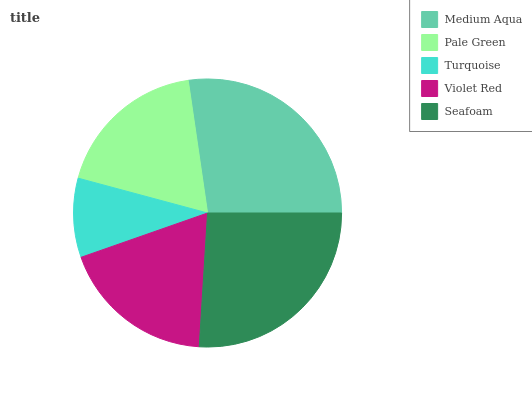Is Turquoise the minimum?
Answer yes or no. Yes. Is Medium Aqua the maximum?
Answer yes or no. Yes. Is Pale Green the minimum?
Answer yes or no. No. Is Pale Green the maximum?
Answer yes or no. No. Is Medium Aqua greater than Pale Green?
Answer yes or no. Yes. Is Pale Green less than Medium Aqua?
Answer yes or no. Yes. Is Pale Green greater than Medium Aqua?
Answer yes or no. No. Is Medium Aqua less than Pale Green?
Answer yes or no. No. Is Violet Red the high median?
Answer yes or no. Yes. Is Violet Red the low median?
Answer yes or no. Yes. Is Pale Green the high median?
Answer yes or no. No. Is Turquoise the low median?
Answer yes or no. No. 